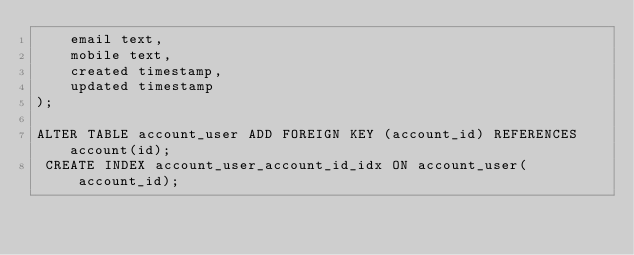<code> <loc_0><loc_0><loc_500><loc_500><_SQL_>    email text,
    mobile text,
    created timestamp,
    updated timestamp
);

ALTER TABLE account_user ADD FOREIGN KEY (account_id) REFERENCES account(id);
 CREATE INDEX account_user_account_id_idx ON account_user(account_id);
</code> 